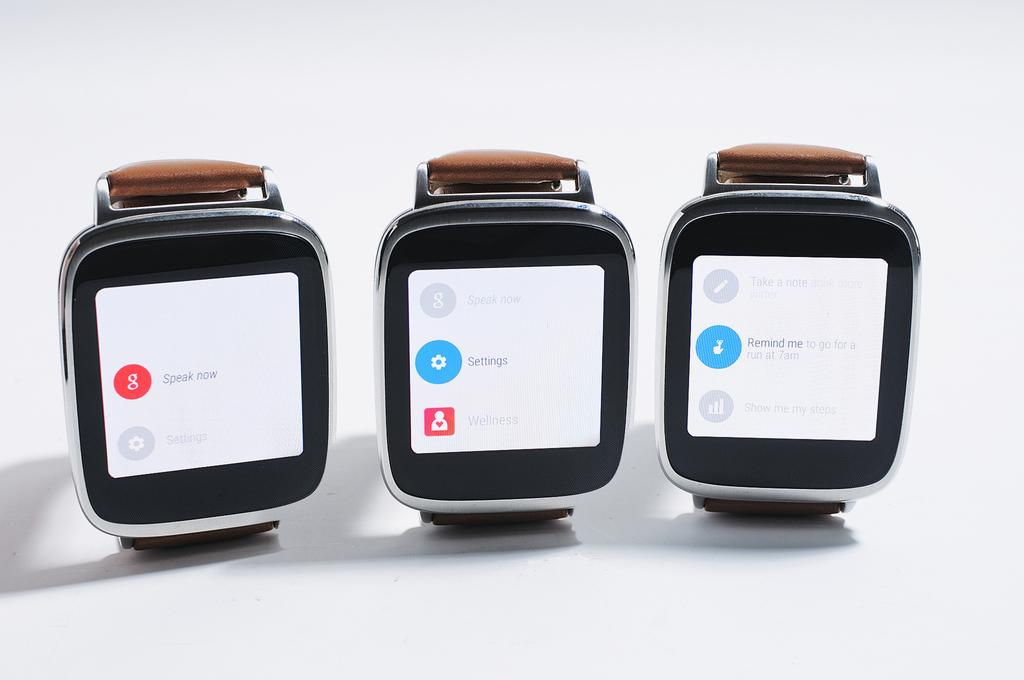<image>
Relay a brief, clear account of the picture shown. Three smart watches are all showing different apps, including a Google app and a settings app. 